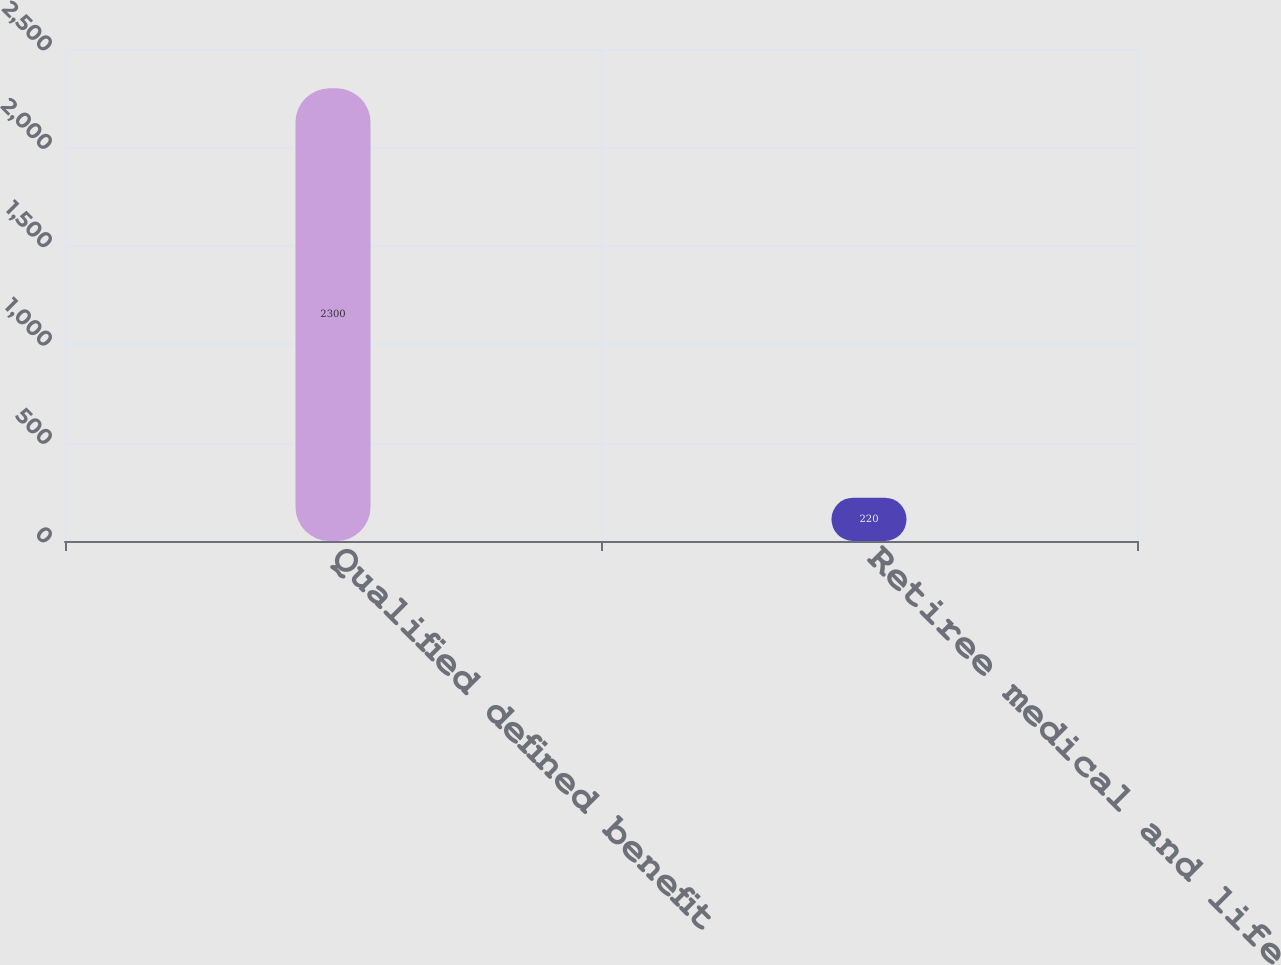Convert chart. <chart><loc_0><loc_0><loc_500><loc_500><bar_chart><fcel>Qualified defined benefit<fcel>Retiree medical and life<nl><fcel>2300<fcel>220<nl></chart> 